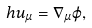<formula> <loc_0><loc_0><loc_500><loc_500>h u _ { \mu } = \nabla _ { \mu } \varphi ,</formula> 